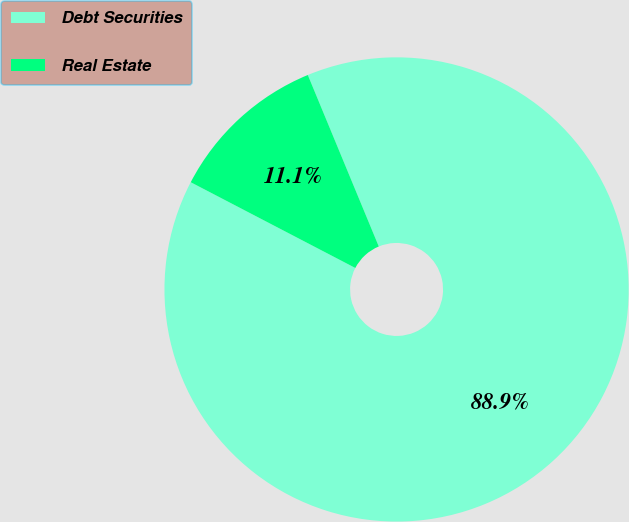Convert chart. <chart><loc_0><loc_0><loc_500><loc_500><pie_chart><fcel>Debt Securities<fcel>Real Estate<nl><fcel>88.89%<fcel>11.11%<nl></chart> 